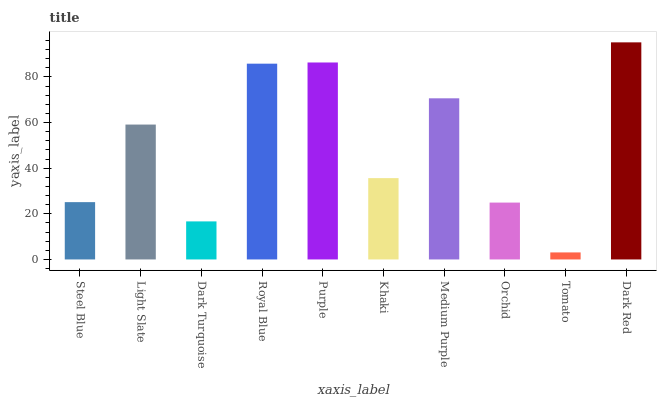Is Tomato the minimum?
Answer yes or no. Yes. Is Dark Red the maximum?
Answer yes or no. Yes. Is Light Slate the minimum?
Answer yes or no. No. Is Light Slate the maximum?
Answer yes or no. No. Is Light Slate greater than Steel Blue?
Answer yes or no. Yes. Is Steel Blue less than Light Slate?
Answer yes or no. Yes. Is Steel Blue greater than Light Slate?
Answer yes or no. No. Is Light Slate less than Steel Blue?
Answer yes or no. No. Is Light Slate the high median?
Answer yes or no. Yes. Is Khaki the low median?
Answer yes or no. Yes. Is Khaki the high median?
Answer yes or no. No. Is Light Slate the low median?
Answer yes or no. No. 